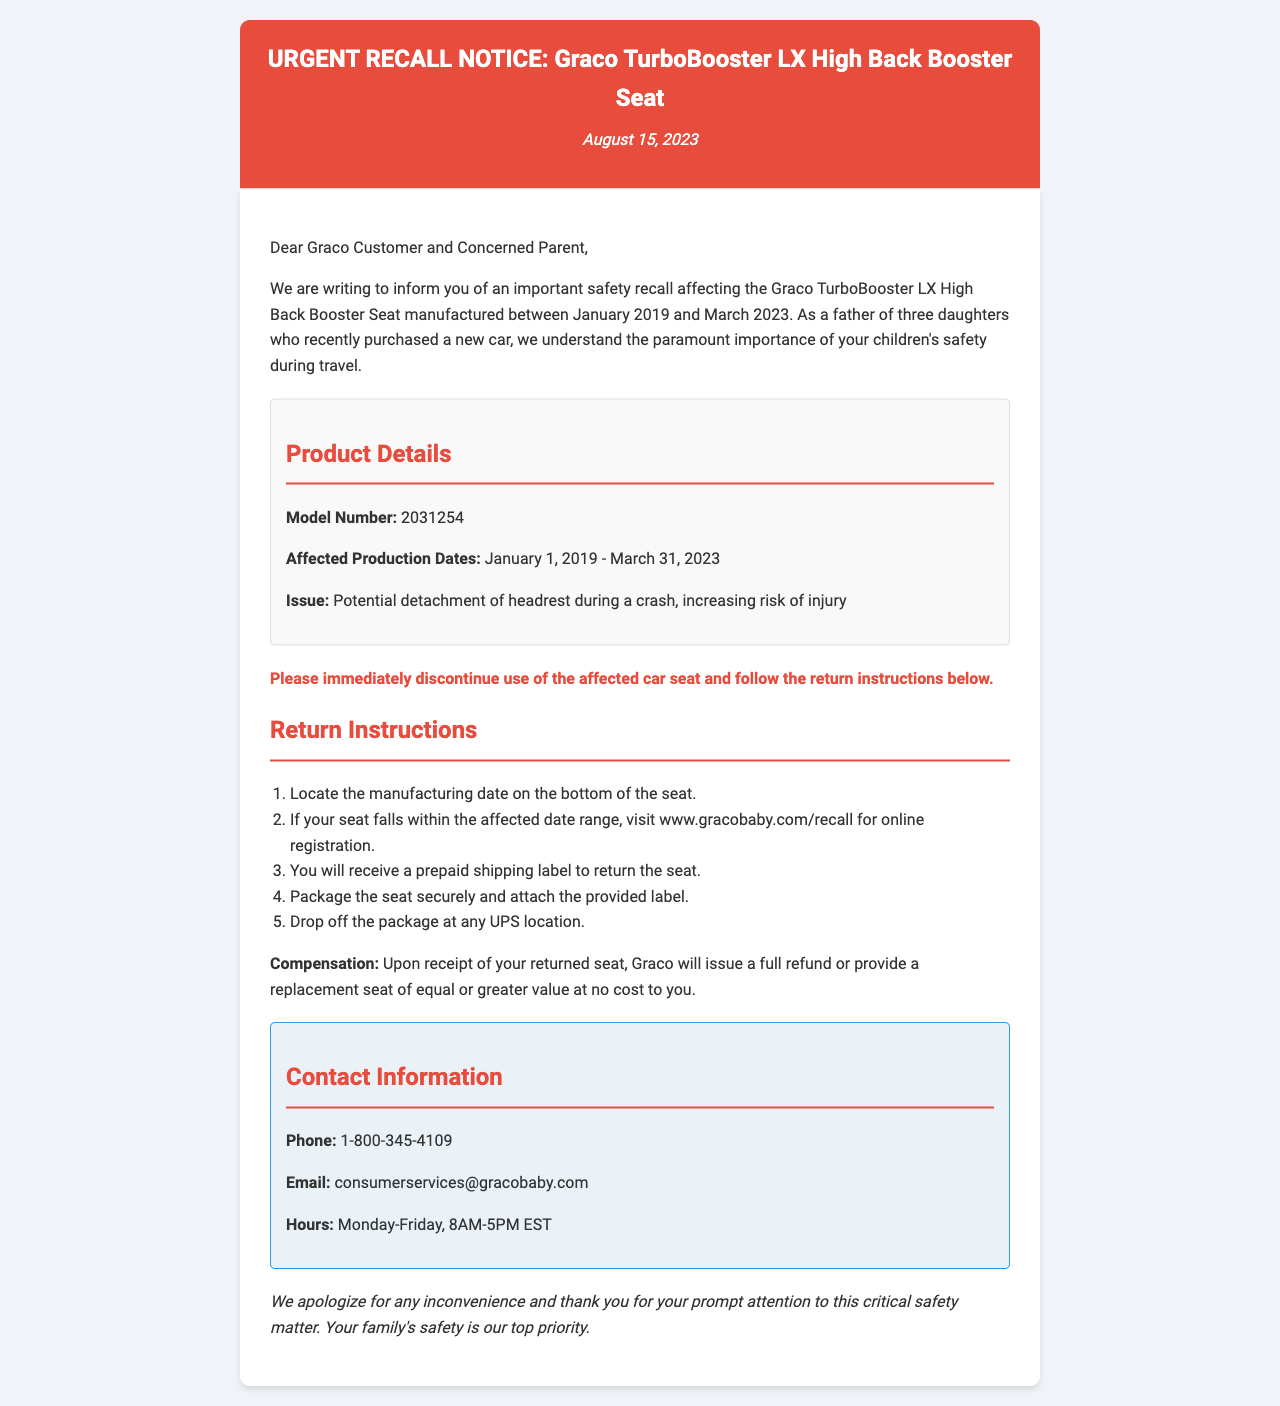What is the model number of the affected car seat? The model number is specified in the product details section of the document as 2031254.
Answer: 2031254 When was the recall notice issued? The date of the recall notice is provided prominently at the top of the document.
Answer: August 15, 2023 What is the issue with the Graco TurboBooster LX? The issue is outlined in the product details section, referring to safety concerns during a crash.
Answer: Potential detachment of headrest during a crash What is the first step in the return instructions? The return instructions are listed in an ordered manner, and the first step requests locating a specific detail on the seat.
Answer: Locate the manufacturing date on the bottom of the seat What will Graco provide upon receipt of the returned seat? The document mentions compensation options available after the returned seat is received.
Answer: Full refund or replacement seat What is the customer service phone number for Graco? The contact information section includes the phone number where customers can reach Graco for inquiries.
Answer: 1-800-345-4109 How long was the affected production period for the car seat? The affected production dates are provided in the product details, indicating the entire range.
Answer: January 1, 2019 - March 31, 2023 What type of document is this? The title and format of the document make it clear it serves a specific purpose regarding safety communication.
Answer: Urgent Recall Notice What is the main audience of this document? The opening paragraph addresses the specific group that should pay attention to this recall, indicating the intended audience.
Answer: Graco Customer and Concerned Parent 